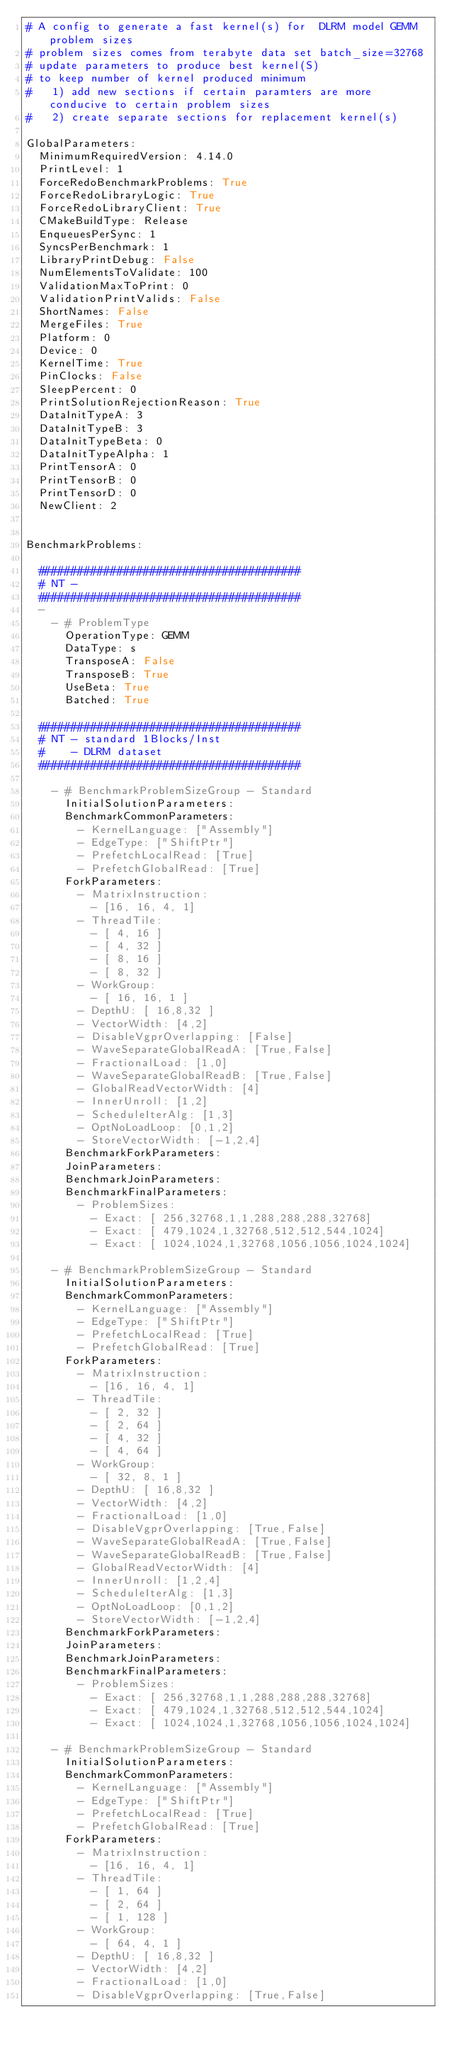Convert code to text. <code><loc_0><loc_0><loc_500><loc_500><_YAML_># A config to generate a fast kernel(s) for  DLRM model GEMM problem sizes
# problem sizes comes from terabyte data set batch_size=32768
# update parameters to produce best kernel(S)
# to keep number of kernel produced minimum 
#   1) add new sections if certain paramters are more conducive to certain problem sizes
#   2) create separate sections for replacement kernel(s)

GlobalParameters:
  MinimumRequiredVersion: 4.14.0
  PrintLevel: 1
  ForceRedoBenchmarkProblems: True
  ForceRedoLibraryLogic: True
  ForceRedoLibraryClient: True
  CMakeBuildType: Release
  EnqueuesPerSync: 1
  SyncsPerBenchmark: 1
  LibraryPrintDebug: False
  NumElementsToValidate: 100
  ValidationMaxToPrint: 0
  ValidationPrintValids: False
  ShortNames: False
  MergeFiles: True
  Platform: 0
  Device: 0
  KernelTime: True
  PinClocks: False
  SleepPercent: 0
  PrintSolutionRejectionReason: True
  DataInitTypeA: 3
  DataInitTypeB: 3
  DataInitTypeBeta: 0
  DataInitTypeAlpha: 1
  PrintTensorA: 0
  PrintTensorB: 0
  PrintTensorD: 0
  NewClient: 2


BenchmarkProblems:

  ########################################
  # NT - 
  ########################################
  -
    - # ProblemType
      OperationType: GEMM
      DataType: s
      TransposeA: False 
      TransposeB: True
      UseBeta: True
      Batched: True

  ########################################
  # NT - standard 1Blocks/Inst
  #    - DLRM dataset
  ########################################

    - # BenchmarkProblemSizeGroup - Standard
      InitialSolutionParameters:
      BenchmarkCommonParameters:
        - KernelLanguage: ["Assembly"]
        - EdgeType: ["ShiftPtr"]
        - PrefetchLocalRead: [True]
        - PrefetchGlobalRead: [True]
      ForkParameters:
        - MatrixInstruction:
          - [16, 16, 4, 1]
        - ThreadTile:
          - [ 4, 16 ]
          - [ 4, 32 ]
          - [ 8, 16 ]
          - [ 8, 32 ]
        - WorkGroup:
          - [ 16, 16, 1 ]
        - DepthU: [ 16,8,32 ]
        - VectorWidth: [4,2]
        - DisableVgprOverlapping: [False]
        - WaveSeparateGlobalReadA: [True,False]
        - FractionalLoad: [1,0]
        - WaveSeparateGlobalReadB: [True,False]
        - GlobalReadVectorWidth: [4]
        - InnerUnroll: [1,2]
        - ScheduleIterAlg: [1,3]
        - OptNoLoadLoop: [0,1,2]
        - StoreVectorWidth: [-1,2,4]
      BenchmarkForkParameters:
      JoinParameters:
      BenchmarkJoinParameters:
      BenchmarkFinalParameters:
        - ProblemSizes:
          - Exact: [ 256,32768,1,1,288,288,288,32768]
          - Exact: [ 479,1024,1,32768,512,512,544,1024]
          - Exact: [ 1024,1024,1,32768,1056,1056,1024,1024]

    - # BenchmarkProblemSizeGroup - Standard
      InitialSolutionParameters:
      BenchmarkCommonParameters:
        - KernelLanguage: ["Assembly"]
        - EdgeType: ["ShiftPtr"]
        - PrefetchLocalRead: [True]
        - PrefetchGlobalRead: [True]
      ForkParameters:
        - MatrixInstruction:
          - [16, 16, 4, 1]
        - ThreadTile:
          - [ 2, 32 ]
          - [ 2, 64 ]
          - [ 4, 32 ]
          - [ 4, 64 ]
        - WorkGroup:
          - [ 32, 8, 1 ]
        - DepthU: [ 16,8,32 ]
        - VectorWidth: [4,2]
        - FractionalLoad: [1,0]
        - DisableVgprOverlapping: [True,False]
        - WaveSeparateGlobalReadA: [True,False]
        - WaveSeparateGlobalReadB: [True,False]
        - GlobalReadVectorWidth: [4]
        - InnerUnroll: [1,2,4]
        - ScheduleIterAlg: [1,3]
        - OptNoLoadLoop: [0,1,2]
        - StoreVectorWidth: [-1,2,4]
      BenchmarkForkParameters:
      JoinParameters:
      BenchmarkJoinParameters:
      BenchmarkFinalParameters:
        - ProblemSizes:
          - Exact: [ 256,32768,1,1,288,288,288,32768]
          - Exact: [ 479,1024,1,32768,512,512,544,1024]
          - Exact: [ 1024,1024,1,32768,1056,1056,1024,1024]

    - # BenchmarkProblemSizeGroup - Standard
      InitialSolutionParameters:
      BenchmarkCommonParameters:
        - KernelLanguage: ["Assembly"]
        - EdgeType: ["ShiftPtr"]
        - PrefetchLocalRead: [True]
        - PrefetchGlobalRead: [True]
      ForkParameters:
        - MatrixInstruction:
          - [16, 16, 4, 1]
        - ThreadTile:
          - [ 1, 64 ]
          - [ 2, 64 ]
          - [ 1, 128 ]
        - WorkGroup:
          - [ 64, 4, 1 ]
        - DepthU: [ 16,8,32 ]
        - VectorWidth: [4,2]
        - FractionalLoad: [1,0]
        - DisableVgprOverlapping: [True,False]</code> 